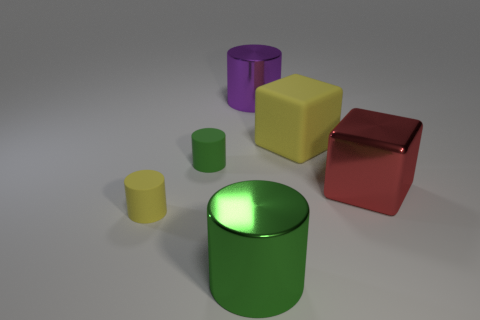Is there any other thing that has the same color as the large rubber thing? Yes, the small rubber cylinder shares the same bright green color as the large one. 